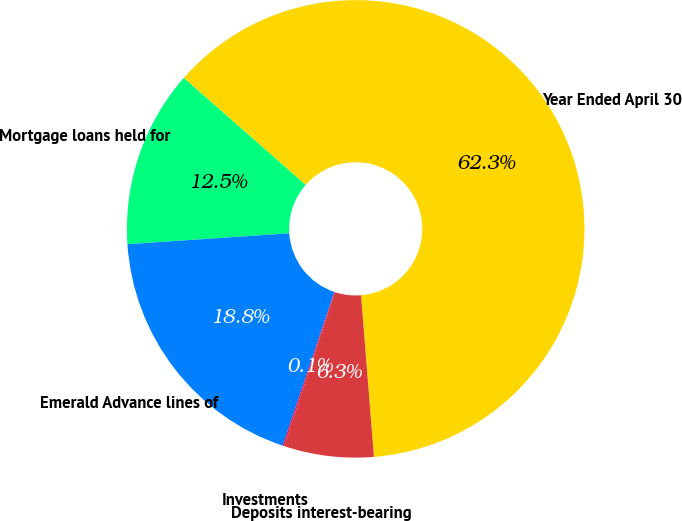<chart> <loc_0><loc_0><loc_500><loc_500><pie_chart><fcel>Year Ended April 30<fcel>Mortgage loans held for<fcel>Emerald Advance lines of<fcel>Investments<fcel>Deposits interest-bearing<nl><fcel>62.26%<fcel>12.54%<fcel>18.76%<fcel>0.11%<fcel>6.33%<nl></chart> 